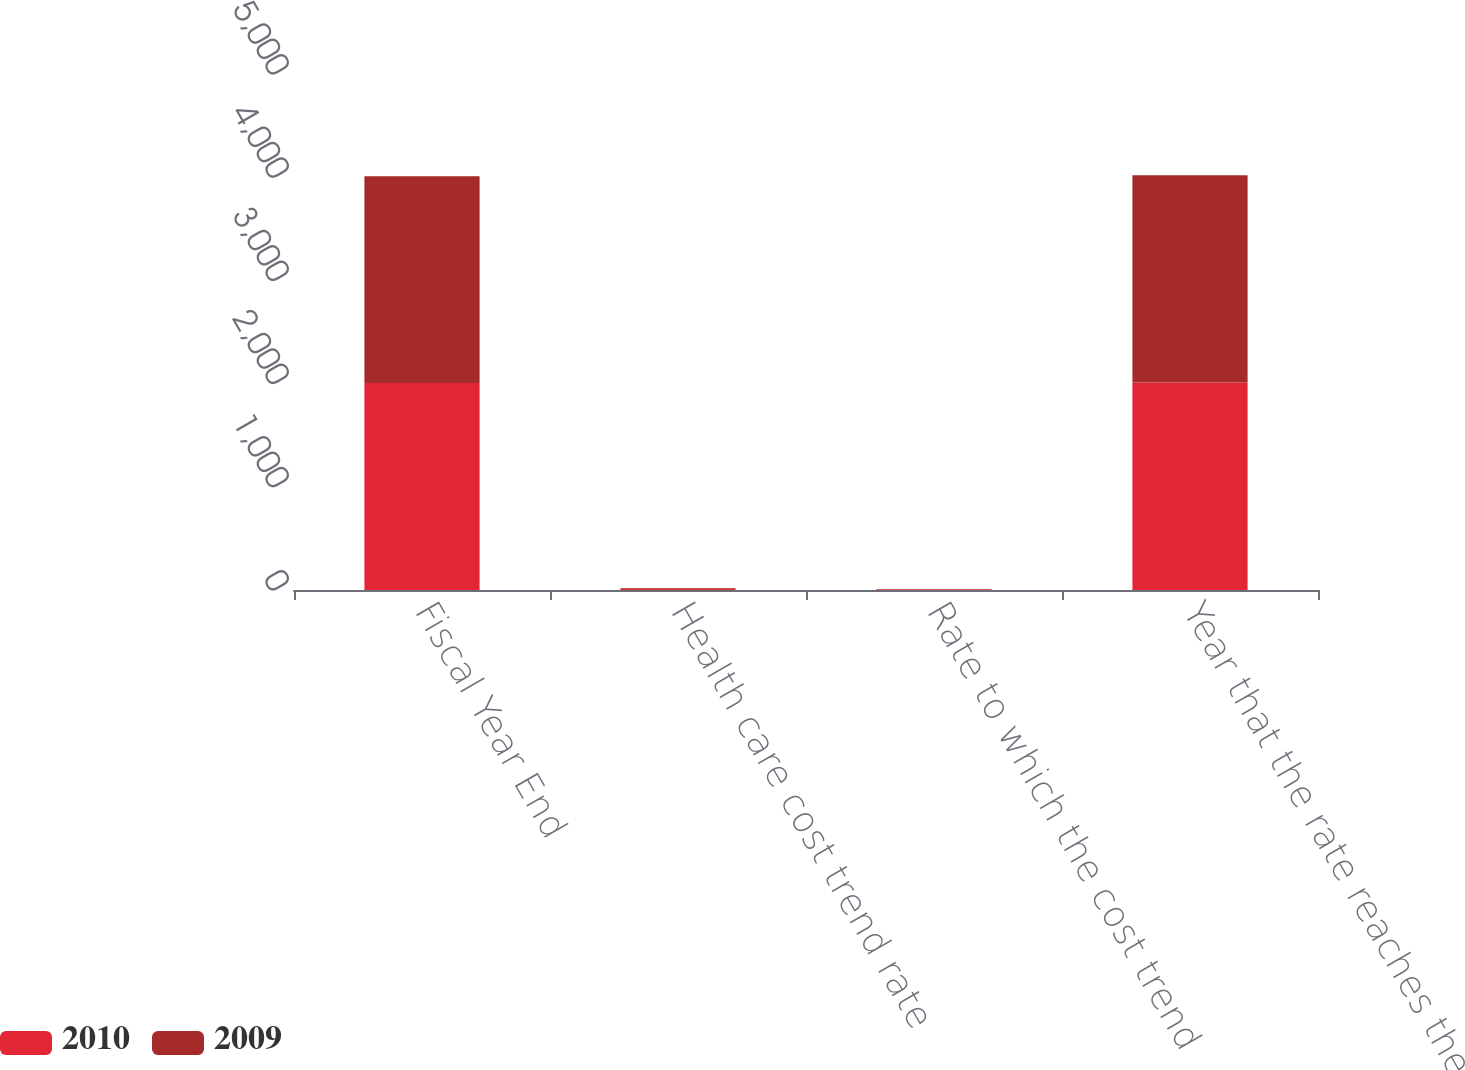<chart> <loc_0><loc_0><loc_500><loc_500><stacked_bar_chart><ecel><fcel>Fiscal Year End<fcel>Health care cost trend rate<fcel>Rate to which the cost trend<fcel>Year that the rate reaches the<nl><fcel>2010<fcel>2005<fcel>9<fcel>5.2<fcel>2010<nl><fcel>2009<fcel>2004<fcel>9<fcel>5.2<fcel>2009<nl></chart> 